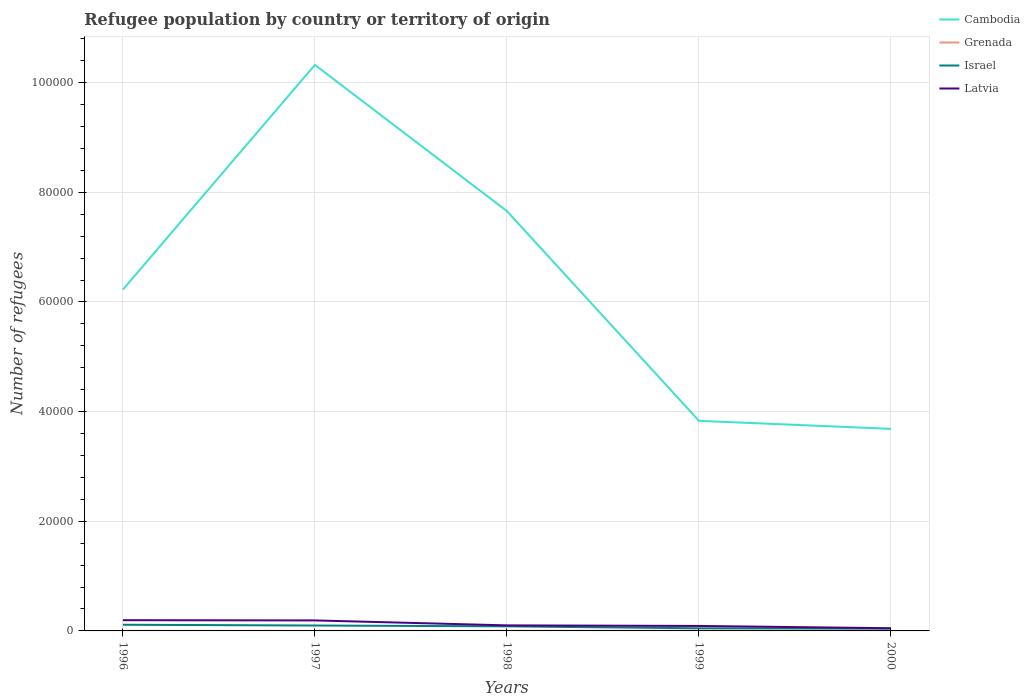How many different coloured lines are there?
Your answer should be compact. 4. Does the line corresponding to Israel intersect with the line corresponding to Latvia?
Ensure brevity in your answer.  No. Across all years, what is the maximum number of refugees in Latvia?
Offer a terse response. 491. In which year was the number of refugees in Grenada maximum?
Provide a short and direct response. 1996. What is the total number of refugees in Latvia in the graph?
Offer a very short reply. 1467. What is the difference between the highest and the second highest number of refugees in Cambodia?
Make the answer very short. 6.64e+04. How many lines are there?
Ensure brevity in your answer.  4. What is the difference between two consecutive major ticks on the Y-axis?
Ensure brevity in your answer.  2.00e+04. Does the graph contain any zero values?
Give a very brief answer. No. Does the graph contain grids?
Your response must be concise. Yes. Where does the legend appear in the graph?
Your answer should be compact. Top right. How many legend labels are there?
Provide a short and direct response. 4. What is the title of the graph?
Keep it short and to the point. Refugee population by country or territory of origin. Does "Channel Islands" appear as one of the legend labels in the graph?
Ensure brevity in your answer.  No. What is the label or title of the X-axis?
Offer a terse response. Years. What is the label or title of the Y-axis?
Give a very brief answer. Number of refugees. What is the Number of refugees of Cambodia in 1996?
Provide a succinct answer. 6.22e+04. What is the Number of refugees of Israel in 1996?
Your response must be concise. 1126. What is the Number of refugees of Latvia in 1996?
Provide a succinct answer. 1958. What is the Number of refugees in Cambodia in 1997?
Your answer should be compact. 1.03e+05. What is the Number of refugees in Grenada in 1997?
Your answer should be very brief. 12. What is the Number of refugees of Israel in 1997?
Give a very brief answer. 987. What is the Number of refugees of Latvia in 1997?
Ensure brevity in your answer.  1915. What is the Number of refugees in Cambodia in 1998?
Your answer should be compact. 7.66e+04. What is the Number of refugees in Grenada in 1998?
Offer a terse response. 20. What is the Number of refugees of Israel in 1998?
Your response must be concise. 835. What is the Number of refugees of Latvia in 1998?
Offer a very short reply. 1013. What is the Number of refugees in Cambodia in 1999?
Your answer should be compact. 3.83e+04. What is the Number of refugees in Grenada in 1999?
Give a very brief answer. 36. What is the Number of refugees in Israel in 1999?
Provide a succinct answer. 478. What is the Number of refugees of Latvia in 1999?
Provide a succinct answer. 907. What is the Number of refugees in Cambodia in 2000?
Give a very brief answer. 3.69e+04. What is the Number of refugees of Israel in 2000?
Ensure brevity in your answer.  416. What is the Number of refugees of Latvia in 2000?
Give a very brief answer. 491. Across all years, what is the maximum Number of refugees of Cambodia?
Provide a succinct answer. 1.03e+05. Across all years, what is the maximum Number of refugees of Grenada?
Offer a very short reply. 36. Across all years, what is the maximum Number of refugees of Israel?
Make the answer very short. 1126. Across all years, what is the maximum Number of refugees of Latvia?
Provide a succinct answer. 1958. Across all years, what is the minimum Number of refugees in Cambodia?
Provide a succinct answer. 3.69e+04. Across all years, what is the minimum Number of refugees of Grenada?
Ensure brevity in your answer.  11. Across all years, what is the minimum Number of refugees of Israel?
Your response must be concise. 416. Across all years, what is the minimum Number of refugees of Latvia?
Provide a short and direct response. 491. What is the total Number of refugees of Cambodia in the graph?
Make the answer very short. 3.17e+05. What is the total Number of refugees in Grenada in the graph?
Keep it short and to the point. 103. What is the total Number of refugees of Israel in the graph?
Offer a terse response. 3842. What is the total Number of refugees in Latvia in the graph?
Make the answer very short. 6284. What is the difference between the Number of refugees of Cambodia in 1996 and that in 1997?
Provide a succinct answer. -4.10e+04. What is the difference between the Number of refugees in Grenada in 1996 and that in 1997?
Offer a terse response. -1. What is the difference between the Number of refugees of Israel in 1996 and that in 1997?
Your response must be concise. 139. What is the difference between the Number of refugees of Latvia in 1996 and that in 1997?
Provide a succinct answer. 43. What is the difference between the Number of refugees in Cambodia in 1996 and that in 1998?
Provide a succinct answer. -1.43e+04. What is the difference between the Number of refugees in Israel in 1996 and that in 1998?
Make the answer very short. 291. What is the difference between the Number of refugees of Latvia in 1996 and that in 1998?
Keep it short and to the point. 945. What is the difference between the Number of refugees of Cambodia in 1996 and that in 1999?
Keep it short and to the point. 2.39e+04. What is the difference between the Number of refugees of Grenada in 1996 and that in 1999?
Give a very brief answer. -25. What is the difference between the Number of refugees in Israel in 1996 and that in 1999?
Ensure brevity in your answer.  648. What is the difference between the Number of refugees in Latvia in 1996 and that in 1999?
Make the answer very short. 1051. What is the difference between the Number of refugees of Cambodia in 1996 and that in 2000?
Provide a short and direct response. 2.54e+04. What is the difference between the Number of refugees of Israel in 1996 and that in 2000?
Ensure brevity in your answer.  710. What is the difference between the Number of refugees of Latvia in 1996 and that in 2000?
Your answer should be very brief. 1467. What is the difference between the Number of refugees in Cambodia in 1997 and that in 1998?
Your answer should be compact. 2.67e+04. What is the difference between the Number of refugees in Grenada in 1997 and that in 1998?
Offer a terse response. -8. What is the difference between the Number of refugees of Israel in 1997 and that in 1998?
Give a very brief answer. 152. What is the difference between the Number of refugees in Latvia in 1997 and that in 1998?
Your answer should be compact. 902. What is the difference between the Number of refugees in Cambodia in 1997 and that in 1999?
Provide a succinct answer. 6.49e+04. What is the difference between the Number of refugees in Israel in 1997 and that in 1999?
Provide a short and direct response. 509. What is the difference between the Number of refugees in Latvia in 1997 and that in 1999?
Offer a very short reply. 1008. What is the difference between the Number of refugees of Cambodia in 1997 and that in 2000?
Ensure brevity in your answer.  6.64e+04. What is the difference between the Number of refugees in Grenada in 1997 and that in 2000?
Make the answer very short. -12. What is the difference between the Number of refugees of Israel in 1997 and that in 2000?
Provide a short and direct response. 571. What is the difference between the Number of refugees of Latvia in 1997 and that in 2000?
Your answer should be very brief. 1424. What is the difference between the Number of refugees in Cambodia in 1998 and that in 1999?
Offer a very short reply. 3.83e+04. What is the difference between the Number of refugees of Grenada in 1998 and that in 1999?
Make the answer very short. -16. What is the difference between the Number of refugees in Israel in 1998 and that in 1999?
Ensure brevity in your answer.  357. What is the difference between the Number of refugees in Latvia in 1998 and that in 1999?
Keep it short and to the point. 106. What is the difference between the Number of refugees in Cambodia in 1998 and that in 2000?
Provide a short and direct response. 3.97e+04. What is the difference between the Number of refugees in Israel in 1998 and that in 2000?
Keep it short and to the point. 419. What is the difference between the Number of refugees of Latvia in 1998 and that in 2000?
Offer a very short reply. 522. What is the difference between the Number of refugees in Cambodia in 1999 and that in 2000?
Keep it short and to the point. 1465. What is the difference between the Number of refugees of Latvia in 1999 and that in 2000?
Make the answer very short. 416. What is the difference between the Number of refugees of Cambodia in 1996 and the Number of refugees of Grenada in 1997?
Your answer should be very brief. 6.22e+04. What is the difference between the Number of refugees in Cambodia in 1996 and the Number of refugees in Israel in 1997?
Give a very brief answer. 6.13e+04. What is the difference between the Number of refugees in Cambodia in 1996 and the Number of refugees in Latvia in 1997?
Offer a terse response. 6.03e+04. What is the difference between the Number of refugees in Grenada in 1996 and the Number of refugees in Israel in 1997?
Offer a terse response. -976. What is the difference between the Number of refugees in Grenada in 1996 and the Number of refugees in Latvia in 1997?
Offer a very short reply. -1904. What is the difference between the Number of refugees of Israel in 1996 and the Number of refugees of Latvia in 1997?
Your response must be concise. -789. What is the difference between the Number of refugees of Cambodia in 1996 and the Number of refugees of Grenada in 1998?
Provide a succinct answer. 6.22e+04. What is the difference between the Number of refugees in Cambodia in 1996 and the Number of refugees in Israel in 1998?
Offer a very short reply. 6.14e+04. What is the difference between the Number of refugees in Cambodia in 1996 and the Number of refugees in Latvia in 1998?
Offer a terse response. 6.12e+04. What is the difference between the Number of refugees in Grenada in 1996 and the Number of refugees in Israel in 1998?
Your answer should be compact. -824. What is the difference between the Number of refugees in Grenada in 1996 and the Number of refugees in Latvia in 1998?
Give a very brief answer. -1002. What is the difference between the Number of refugees of Israel in 1996 and the Number of refugees of Latvia in 1998?
Keep it short and to the point. 113. What is the difference between the Number of refugees of Cambodia in 1996 and the Number of refugees of Grenada in 1999?
Your answer should be compact. 6.22e+04. What is the difference between the Number of refugees of Cambodia in 1996 and the Number of refugees of Israel in 1999?
Your response must be concise. 6.18e+04. What is the difference between the Number of refugees of Cambodia in 1996 and the Number of refugees of Latvia in 1999?
Provide a succinct answer. 6.13e+04. What is the difference between the Number of refugees of Grenada in 1996 and the Number of refugees of Israel in 1999?
Your answer should be very brief. -467. What is the difference between the Number of refugees of Grenada in 1996 and the Number of refugees of Latvia in 1999?
Your answer should be compact. -896. What is the difference between the Number of refugees of Israel in 1996 and the Number of refugees of Latvia in 1999?
Give a very brief answer. 219. What is the difference between the Number of refugees of Cambodia in 1996 and the Number of refugees of Grenada in 2000?
Offer a terse response. 6.22e+04. What is the difference between the Number of refugees of Cambodia in 1996 and the Number of refugees of Israel in 2000?
Your answer should be very brief. 6.18e+04. What is the difference between the Number of refugees of Cambodia in 1996 and the Number of refugees of Latvia in 2000?
Offer a very short reply. 6.18e+04. What is the difference between the Number of refugees of Grenada in 1996 and the Number of refugees of Israel in 2000?
Your answer should be very brief. -405. What is the difference between the Number of refugees of Grenada in 1996 and the Number of refugees of Latvia in 2000?
Offer a terse response. -480. What is the difference between the Number of refugees of Israel in 1996 and the Number of refugees of Latvia in 2000?
Make the answer very short. 635. What is the difference between the Number of refugees in Cambodia in 1997 and the Number of refugees in Grenada in 1998?
Your answer should be compact. 1.03e+05. What is the difference between the Number of refugees in Cambodia in 1997 and the Number of refugees in Israel in 1998?
Offer a terse response. 1.02e+05. What is the difference between the Number of refugees of Cambodia in 1997 and the Number of refugees of Latvia in 1998?
Offer a terse response. 1.02e+05. What is the difference between the Number of refugees of Grenada in 1997 and the Number of refugees of Israel in 1998?
Offer a terse response. -823. What is the difference between the Number of refugees of Grenada in 1997 and the Number of refugees of Latvia in 1998?
Provide a short and direct response. -1001. What is the difference between the Number of refugees in Israel in 1997 and the Number of refugees in Latvia in 1998?
Offer a terse response. -26. What is the difference between the Number of refugees of Cambodia in 1997 and the Number of refugees of Grenada in 1999?
Make the answer very short. 1.03e+05. What is the difference between the Number of refugees of Cambodia in 1997 and the Number of refugees of Israel in 1999?
Make the answer very short. 1.03e+05. What is the difference between the Number of refugees in Cambodia in 1997 and the Number of refugees in Latvia in 1999?
Ensure brevity in your answer.  1.02e+05. What is the difference between the Number of refugees of Grenada in 1997 and the Number of refugees of Israel in 1999?
Give a very brief answer. -466. What is the difference between the Number of refugees in Grenada in 1997 and the Number of refugees in Latvia in 1999?
Provide a short and direct response. -895. What is the difference between the Number of refugees in Israel in 1997 and the Number of refugees in Latvia in 1999?
Your response must be concise. 80. What is the difference between the Number of refugees of Cambodia in 1997 and the Number of refugees of Grenada in 2000?
Give a very brief answer. 1.03e+05. What is the difference between the Number of refugees of Cambodia in 1997 and the Number of refugees of Israel in 2000?
Give a very brief answer. 1.03e+05. What is the difference between the Number of refugees of Cambodia in 1997 and the Number of refugees of Latvia in 2000?
Provide a short and direct response. 1.03e+05. What is the difference between the Number of refugees of Grenada in 1997 and the Number of refugees of Israel in 2000?
Your answer should be very brief. -404. What is the difference between the Number of refugees of Grenada in 1997 and the Number of refugees of Latvia in 2000?
Your response must be concise. -479. What is the difference between the Number of refugees in Israel in 1997 and the Number of refugees in Latvia in 2000?
Ensure brevity in your answer.  496. What is the difference between the Number of refugees of Cambodia in 1998 and the Number of refugees of Grenada in 1999?
Provide a succinct answer. 7.65e+04. What is the difference between the Number of refugees of Cambodia in 1998 and the Number of refugees of Israel in 1999?
Your answer should be very brief. 7.61e+04. What is the difference between the Number of refugees in Cambodia in 1998 and the Number of refugees in Latvia in 1999?
Ensure brevity in your answer.  7.57e+04. What is the difference between the Number of refugees of Grenada in 1998 and the Number of refugees of Israel in 1999?
Ensure brevity in your answer.  -458. What is the difference between the Number of refugees in Grenada in 1998 and the Number of refugees in Latvia in 1999?
Your answer should be very brief. -887. What is the difference between the Number of refugees of Israel in 1998 and the Number of refugees of Latvia in 1999?
Offer a very short reply. -72. What is the difference between the Number of refugees in Cambodia in 1998 and the Number of refugees in Grenada in 2000?
Provide a short and direct response. 7.66e+04. What is the difference between the Number of refugees in Cambodia in 1998 and the Number of refugees in Israel in 2000?
Provide a succinct answer. 7.62e+04. What is the difference between the Number of refugees in Cambodia in 1998 and the Number of refugees in Latvia in 2000?
Provide a succinct answer. 7.61e+04. What is the difference between the Number of refugees in Grenada in 1998 and the Number of refugees in Israel in 2000?
Make the answer very short. -396. What is the difference between the Number of refugees of Grenada in 1998 and the Number of refugees of Latvia in 2000?
Give a very brief answer. -471. What is the difference between the Number of refugees of Israel in 1998 and the Number of refugees of Latvia in 2000?
Offer a terse response. 344. What is the difference between the Number of refugees in Cambodia in 1999 and the Number of refugees in Grenada in 2000?
Provide a succinct answer. 3.83e+04. What is the difference between the Number of refugees of Cambodia in 1999 and the Number of refugees of Israel in 2000?
Provide a short and direct response. 3.79e+04. What is the difference between the Number of refugees of Cambodia in 1999 and the Number of refugees of Latvia in 2000?
Give a very brief answer. 3.78e+04. What is the difference between the Number of refugees of Grenada in 1999 and the Number of refugees of Israel in 2000?
Offer a terse response. -380. What is the difference between the Number of refugees of Grenada in 1999 and the Number of refugees of Latvia in 2000?
Give a very brief answer. -455. What is the average Number of refugees in Cambodia per year?
Give a very brief answer. 6.34e+04. What is the average Number of refugees of Grenada per year?
Make the answer very short. 20.6. What is the average Number of refugees of Israel per year?
Make the answer very short. 768.4. What is the average Number of refugees of Latvia per year?
Make the answer very short. 1256.8. In the year 1996, what is the difference between the Number of refugees in Cambodia and Number of refugees in Grenada?
Your response must be concise. 6.22e+04. In the year 1996, what is the difference between the Number of refugees of Cambodia and Number of refugees of Israel?
Ensure brevity in your answer.  6.11e+04. In the year 1996, what is the difference between the Number of refugees of Cambodia and Number of refugees of Latvia?
Give a very brief answer. 6.03e+04. In the year 1996, what is the difference between the Number of refugees in Grenada and Number of refugees in Israel?
Give a very brief answer. -1115. In the year 1996, what is the difference between the Number of refugees of Grenada and Number of refugees of Latvia?
Your response must be concise. -1947. In the year 1996, what is the difference between the Number of refugees in Israel and Number of refugees in Latvia?
Your response must be concise. -832. In the year 1997, what is the difference between the Number of refugees of Cambodia and Number of refugees of Grenada?
Provide a succinct answer. 1.03e+05. In the year 1997, what is the difference between the Number of refugees in Cambodia and Number of refugees in Israel?
Provide a short and direct response. 1.02e+05. In the year 1997, what is the difference between the Number of refugees of Cambodia and Number of refugees of Latvia?
Provide a succinct answer. 1.01e+05. In the year 1997, what is the difference between the Number of refugees of Grenada and Number of refugees of Israel?
Keep it short and to the point. -975. In the year 1997, what is the difference between the Number of refugees of Grenada and Number of refugees of Latvia?
Provide a short and direct response. -1903. In the year 1997, what is the difference between the Number of refugees of Israel and Number of refugees of Latvia?
Your answer should be very brief. -928. In the year 1998, what is the difference between the Number of refugees in Cambodia and Number of refugees in Grenada?
Your response must be concise. 7.66e+04. In the year 1998, what is the difference between the Number of refugees of Cambodia and Number of refugees of Israel?
Your response must be concise. 7.57e+04. In the year 1998, what is the difference between the Number of refugees of Cambodia and Number of refugees of Latvia?
Ensure brevity in your answer.  7.56e+04. In the year 1998, what is the difference between the Number of refugees of Grenada and Number of refugees of Israel?
Your answer should be very brief. -815. In the year 1998, what is the difference between the Number of refugees of Grenada and Number of refugees of Latvia?
Your answer should be very brief. -993. In the year 1998, what is the difference between the Number of refugees of Israel and Number of refugees of Latvia?
Ensure brevity in your answer.  -178. In the year 1999, what is the difference between the Number of refugees in Cambodia and Number of refugees in Grenada?
Your response must be concise. 3.83e+04. In the year 1999, what is the difference between the Number of refugees in Cambodia and Number of refugees in Israel?
Provide a succinct answer. 3.78e+04. In the year 1999, what is the difference between the Number of refugees of Cambodia and Number of refugees of Latvia?
Give a very brief answer. 3.74e+04. In the year 1999, what is the difference between the Number of refugees in Grenada and Number of refugees in Israel?
Provide a short and direct response. -442. In the year 1999, what is the difference between the Number of refugees of Grenada and Number of refugees of Latvia?
Ensure brevity in your answer.  -871. In the year 1999, what is the difference between the Number of refugees of Israel and Number of refugees of Latvia?
Provide a short and direct response. -429. In the year 2000, what is the difference between the Number of refugees of Cambodia and Number of refugees of Grenada?
Your response must be concise. 3.68e+04. In the year 2000, what is the difference between the Number of refugees in Cambodia and Number of refugees in Israel?
Offer a terse response. 3.64e+04. In the year 2000, what is the difference between the Number of refugees in Cambodia and Number of refugees in Latvia?
Provide a short and direct response. 3.64e+04. In the year 2000, what is the difference between the Number of refugees of Grenada and Number of refugees of Israel?
Your answer should be compact. -392. In the year 2000, what is the difference between the Number of refugees in Grenada and Number of refugees in Latvia?
Make the answer very short. -467. In the year 2000, what is the difference between the Number of refugees in Israel and Number of refugees in Latvia?
Keep it short and to the point. -75. What is the ratio of the Number of refugees in Cambodia in 1996 to that in 1997?
Make the answer very short. 0.6. What is the ratio of the Number of refugees of Israel in 1996 to that in 1997?
Offer a terse response. 1.14. What is the ratio of the Number of refugees of Latvia in 1996 to that in 1997?
Ensure brevity in your answer.  1.02. What is the ratio of the Number of refugees in Cambodia in 1996 to that in 1998?
Give a very brief answer. 0.81. What is the ratio of the Number of refugees of Grenada in 1996 to that in 1998?
Offer a very short reply. 0.55. What is the ratio of the Number of refugees of Israel in 1996 to that in 1998?
Offer a very short reply. 1.35. What is the ratio of the Number of refugees of Latvia in 1996 to that in 1998?
Ensure brevity in your answer.  1.93. What is the ratio of the Number of refugees of Cambodia in 1996 to that in 1999?
Your answer should be compact. 1.62. What is the ratio of the Number of refugees in Grenada in 1996 to that in 1999?
Ensure brevity in your answer.  0.31. What is the ratio of the Number of refugees in Israel in 1996 to that in 1999?
Offer a very short reply. 2.36. What is the ratio of the Number of refugees of Latvia in 1996 to that in 1999?
Your answer should be compact. 2.16. What is the ratio of the Number of refugees of Cambodia in 1996 to that in 2000?
Your answer should be very brief. 1.69. What is the ratio of the Number of refugees of Grenada in 1996 to that in 2000?
Your answer should be compact. 0.46. What is the ratio of the Number of refugees in Israel in 1996 to that in 2000?
Keep it short and to the point. 2.71. What is the ratio of the Number of refugees of Latvia in 1996 to that in 2000?
Give a very brief answer. 3.99. What is the ratio of the Number of refugees in Cambodia in 1997 to that in 1998?
Make the answer very short. 1.35. What is the ratio of the Number of refugees in Israel in 1997 to that in 1998?
Your answer should be compact. 1.18. What is the ratio of the Number of refugees of Latvia in 1997 to that in 1998?
Keep it short and to the point. 1.89. What is the ratio of the Number of refugees of Cambodia in 1997 to that in 1999?
Your answer should be compact. 2.69. What is the ratio of the Number of refugees in Israel in 1997 to that in 1999?
Offer a very short reply. 2.06. What is the ratio of the Number of refugees of Latvia in 1997 to that in 1999?
Provide a succinct answer. 2.11. What is the ratio of the Number of refugees in Cambodia in 1997 to that in 2000?
Offer a terse response. 2.8. What is the ratio of the Number of refugees of Israel in 1997 to that in 2000?
Offer a very short reply. 2.37. What is the ratio of the Number of refugees in Latvia in 1997 to that in 2000?
Provide a succinct answer. 3.9. What is the ratio of the Number of refugees in Cambodia in 1998 to that in 1999?
Your answer should be compact. 2. What is the ratio of the Number of refugees of Grenada in 1998 to that in 1999?
Ensure brevity in your answer.  0.56. What is the ratio of the Number of refugees in Israel in 1998 to that in 1999?
Give a very brief answer. 1.75. What is the ratio of the Number of refugees in Latvia in 1998 to that in 1999?
Give a very brief answer. 1.12. What is the ratio of the Number of refugees of Cambodia in 1998 to that in 2000?
Offer a terse response. 2.08. What is the ratio of the Number of refugees of Israel in 1998 to that in 2000?
Offer a very short reply. 2.01. What is the ratio of the Number of refugees in Latvia in 1998 to that in 2000?
Provide a succinct answer. 2.06. What is the ratio of the Number of refugees of Cambodia in 1999 to that in 2000?
Your answer should be compact. 1.04. What is the ratio of the Number of refugees of Israel in 1999 to that in 2000?
Your response must be concise. 1.15. What is the ratio of the Number of refugees of Latvia in 1999 to that in 2000?
Your answer should be compact. 1.85. What is the difference between the highest and the second highest Number of refugees in Cambodia?
Your response must be concise. 2.67e+04. What is the difference between the highest and the second highest Number of refugees in Israel?
Ensure brevity in your answer.  139. What is the difference between the highest and the second highest Number of refugees in Latvia?
Your response must be concise. 43. What is the difference between the highest and the lowest Number of refugees in Cambodia?
Your answer should be very brief. 6.64e+04. What is the difference between the highest and the lowest Number of refugees of Israel?
Provide a succinct answer. 710. What is the difference between the highest and the lowest Number of refugees of Latvia?
Make the answer very short. 1467. 